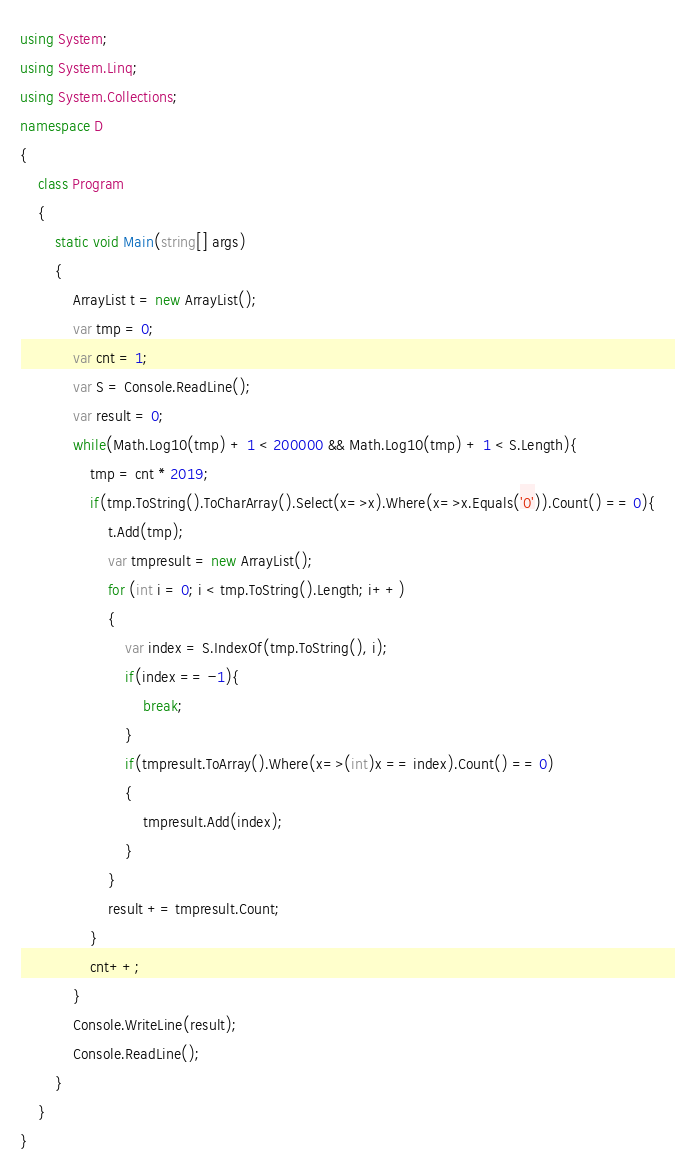<code> <loc_0><loc_0><loc_500><loc_500><_C#_>using System;
using System.Linq;
using System.Collections;
namespace D
{
    class Program
    {
        static void Main(string[] args)
        {
            ArrayList t = new ArrayList();
            var tmp = 0;
            var cnt = 1;
            var S = Console.ReadLine();
            var result = 0;
            while(Math.Log10(tmp) + 1 < 200000 && Math.Log10(tmp) + 1 < S.Length){
                tmp = cnt * 2019;
                if(tmp.ToString().ToCharArray().Select(x=>x).Where(x=>x.Equals('0')).Count() == 0){
                    t.Add(tmp);
                    var tmpresult = new ArrayList();
                    for (int i = 0; i < tmp.ToString().Length; i++)
                    {
                        var index = S.IndexOf(tmp.ToString(), i);
                        if(index == -1){
                            break;
                        }
                        if(tmpresult.ToArray().Where(x=>(int)x == index).Count() == 0)
                        {
                            tmpresult.Add(index);
                        }
                    }
                    result += tmpresult.Count;
                }
                cnt++;
            }
            Console.WriteLine(result);
            Console.ReadLine();
        }
    }
}
</code> 